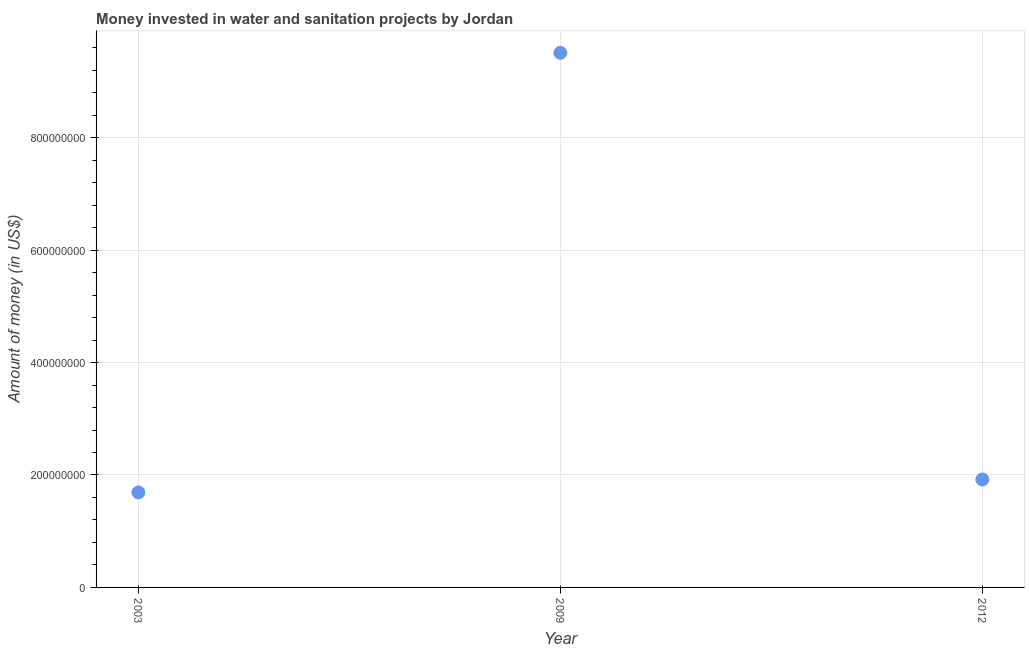What is the investment in 2003?
Your response must be concise. 1.69e+08. Across all years, what is the maximum investment?
Your answer should be compact. 9.51e+08. Across all years, what is the minimum investment?
Make the answer very short. 1.69e+08. What is the sum of the investment?
Provide a short and direct response. 1.31e+09. What is the difference between the investment in 2003 and 2009?
Ensure brevity in your answer.  -7.82e+08. What is the average investment per year?
Offer a terse response. 4.37e+08. What is the median investment?
Your answer should be very brief. 1.92e+08. In how many years, is the investment greater than 200000000 US$?
Your answer should be compact. 1. Do a majority of the years between 2009 and 2012 (inclusive) have investment greater than 200000000 US$?
Keep it short and to the point. No. What is the ratio of the investment in 2003 to that in 2012?
Your answer should be compact. 0.88. What is the difference between the highest and the second highest investment?
Keep it short and to the point. 7.59e+08. What is the difference between the highest and the lowest investment?
Give a very brief answer. 7.82e+08. In how many years, is the investment greater than the average investment taken over all years?
Offer a very short reply. 1. Does the investment monotonically increase over the years?
Provide a short and direct response. No. What is the difference between two consecutive major ticks on the Y-axis?
Keep it short and to the point. 2.00e+08. Are the values on the major ticks of Y-axis written in scientific E-notation?
Offer a very short reply. No. What is the title of the graph?
Give a very brief answer. Money invested in water and sanitation projects by Jordan. What is the label or title of the X-axis?
Your response must be concise. Year. What is the label or title of the Y-axis?
Offer a terse response. Amount of money (in US$). What is the Amount of money (in US$) in 2003?
Keep it short and to the point. 1.69e+08. What is the Amount of money (in US$) in 2009?
Offer a very short reply. 9.51e+08. What is the Amount of money (in US$) in 2012?
Make the answer very short. 1.92e+08. What is the difference between the Amount of money (in US$) in 2003 and 2009?
Offer a terse response. -7.82e+08. What is the difference between the Amount of money (in US$) in 2003 and 2012?
Make the answer very short. -2.30e+07. What is the difference between the Amount of money (in US$) in 2009 and 2012?
Make the answer very short. 7.59e+08. What is the ratio of the Amount of money (in US$) in 2003 to that in 2009?
Provide a succinct answer. 0.18. What is the ratio of the Amount of money (in US$) in 2003 to that in 2012?
Your response must be concise. 0.88. What is the ratio of the Amount of money (in US$) in 2009 to that in 2012?
Provide a short and direct response. 4.95. 